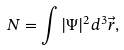Convert formula to latex. <formula><loc_0><loc_0><loc_500><loc_500>N = \int | \Psi | ^ { 2 } d ^ { 3 } \vec { r } ,</formula> 